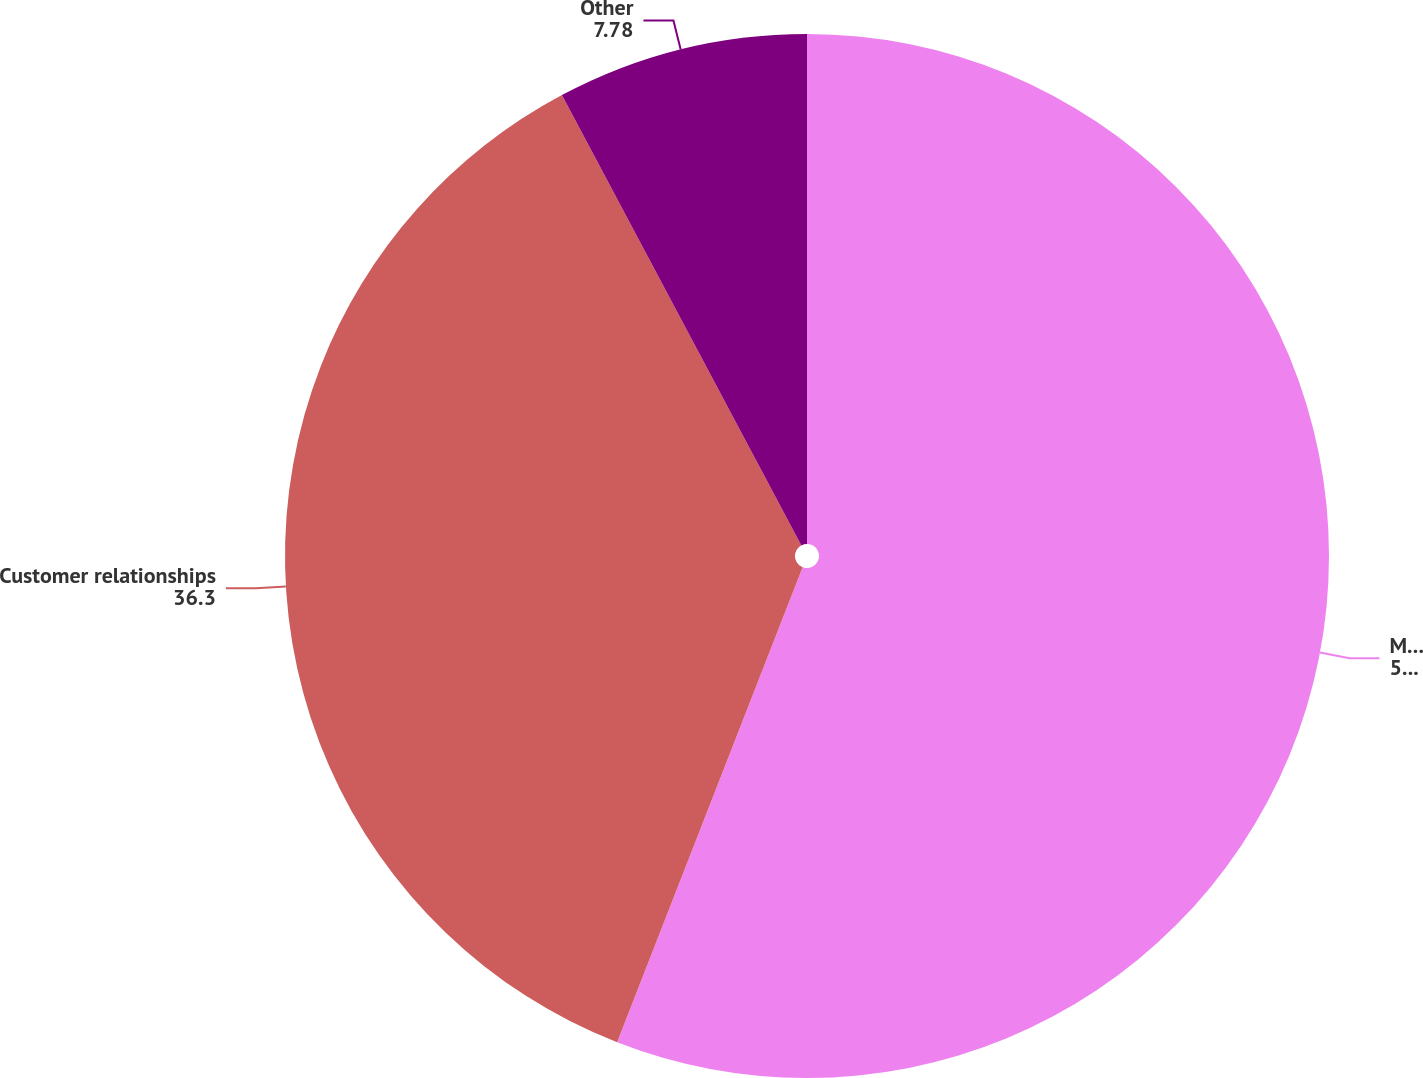Convert chart to OTSL. <chart><loc_0><loc_0><loc_500><loc_500><pie_chart><fcel>Mortgage servicing rights<fcel>Customer relationships<fcel>Other<nl><fcel>55.93%<fcel>36.3%<fcel>7.78%<nl></chart> 